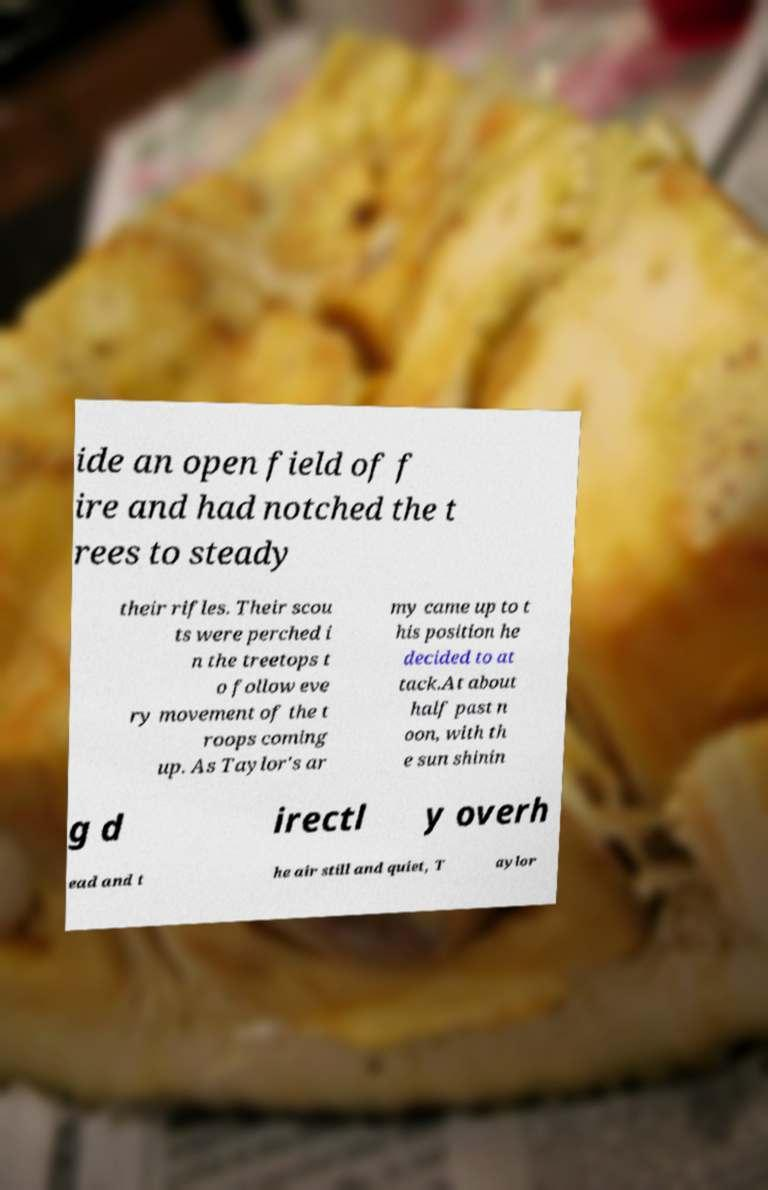Can you read and provide the text displayed in the image?This photo seems to have some interesting text. Can you extract and type it out for me? ide an open field of f ire and had notched the t rees to steady their rifles. Their scou ts were perched i n the treetops t o follow eve ry movement of the t roops coming up. As Taylor's ar my came up to t his position he decided to at tack.At about half past n oon, with th e sun shinin g d irectl y overh ead and t he air still and quiet, T aylor 